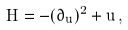<formula> <loc_0><loc_0><loc_500><loc_500>H = - ( \partial _ { u } ) ^ { 2 } + u \, ,</formula> 